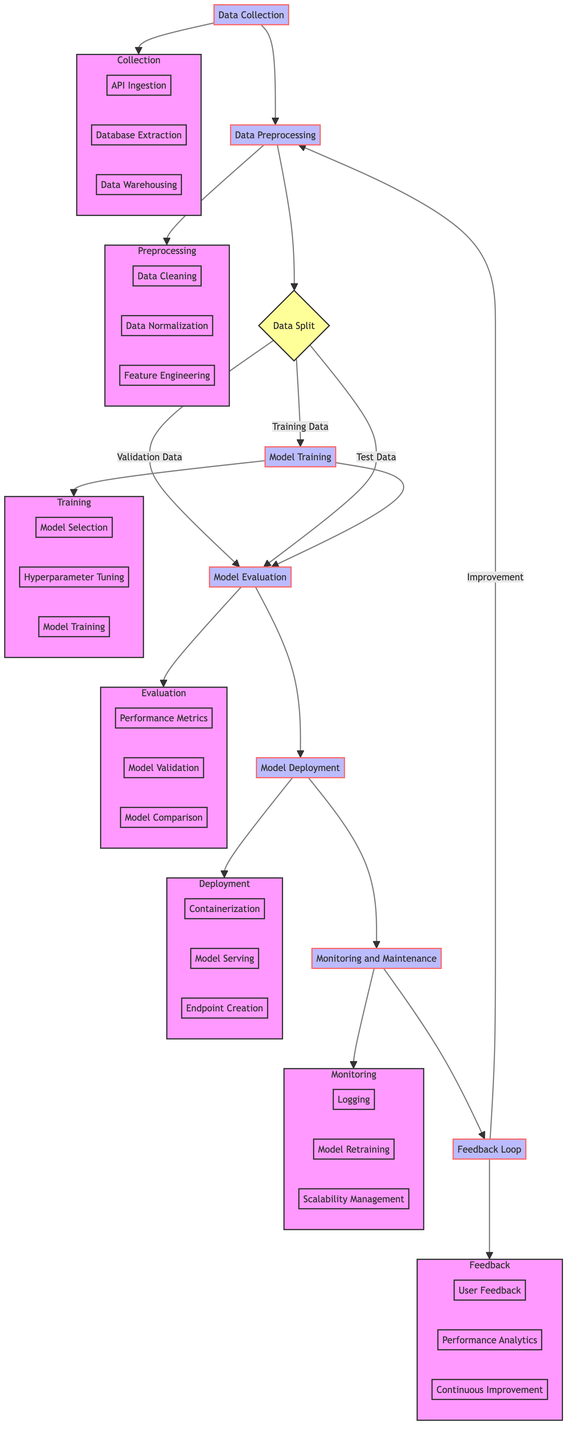What is the first step in the pipeline? The diagram starts with "Data Collection" which indicates that collecting raw data is the first action in the process.
Answer: Data Collection How many main processes are there in the pipeline? The main processes outlined in the diagram include seven distinct nodes from Data Collection to Feedback Loop, which indicates the number of primary steps in the pipeline.
Answer: Seven What type of node is "Data Split"? "Data Split" is represented as a decision point since it defines how the data is divided into different subsets, reflecting a choice about the flow of data.
Answer: Decision Which action is associated with the "Model Training" node? The actions within the "Model Training" node include three specific tasks: Model Selection, Hyperparameter Tuning, and Model Training; listing these actions gives clarity on what is involved in this step.
Answer: Model Selection, Hyperparameter Tuning, Model Training What comes after "Model Evaluation"? Following the "Model Evaluation" step as per the diagram, the next step is "Model Deployment", indicating the sequence of actions taken post-evaluation.
Answer: Model Deployment How does the Feedback Loop relate to Data Preprocessing? The Feedback Loop connects back to Data Preprocessing, indicating that feedback received can lead to improvements in the data preparation stage, showing a cyclical relationship in the pipeline.
Answer: Improvement How many actions are part of "Monitoring and Maintenance"? Within "Monitoring and Maintenance" there are three actions listed: Logging and Monitoring, Model Retraining, and Scalability Management, detailing the ongoing management tasks.
Answer: Three What is the relationship between "Model Training" and "Model Evaluation"? "Model Training" and "Model Evaluation" are sequentially connected; once the model is trained, it subsequently undergoes evaluation to assess its performance.
Answer: Sequential connection What is the sub-process included under "Deployment"? Within the "Deployment" stage, the sub-processes include Containerization, Model Serving, and Endpoint Creation, outlining what happens during this phase of the pipeline.
Answer: Containerization, Model Serving, Endpoint Creation 